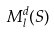<formula> <loc_0><loc_0><loc_500><loc_500>M _ { l } ^ { d } ( S )</formula> 